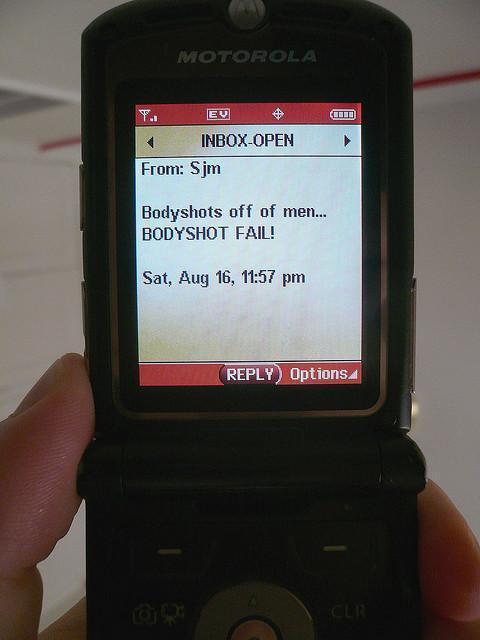How many kites are in the sky?
Give a very brief answer. 0. 